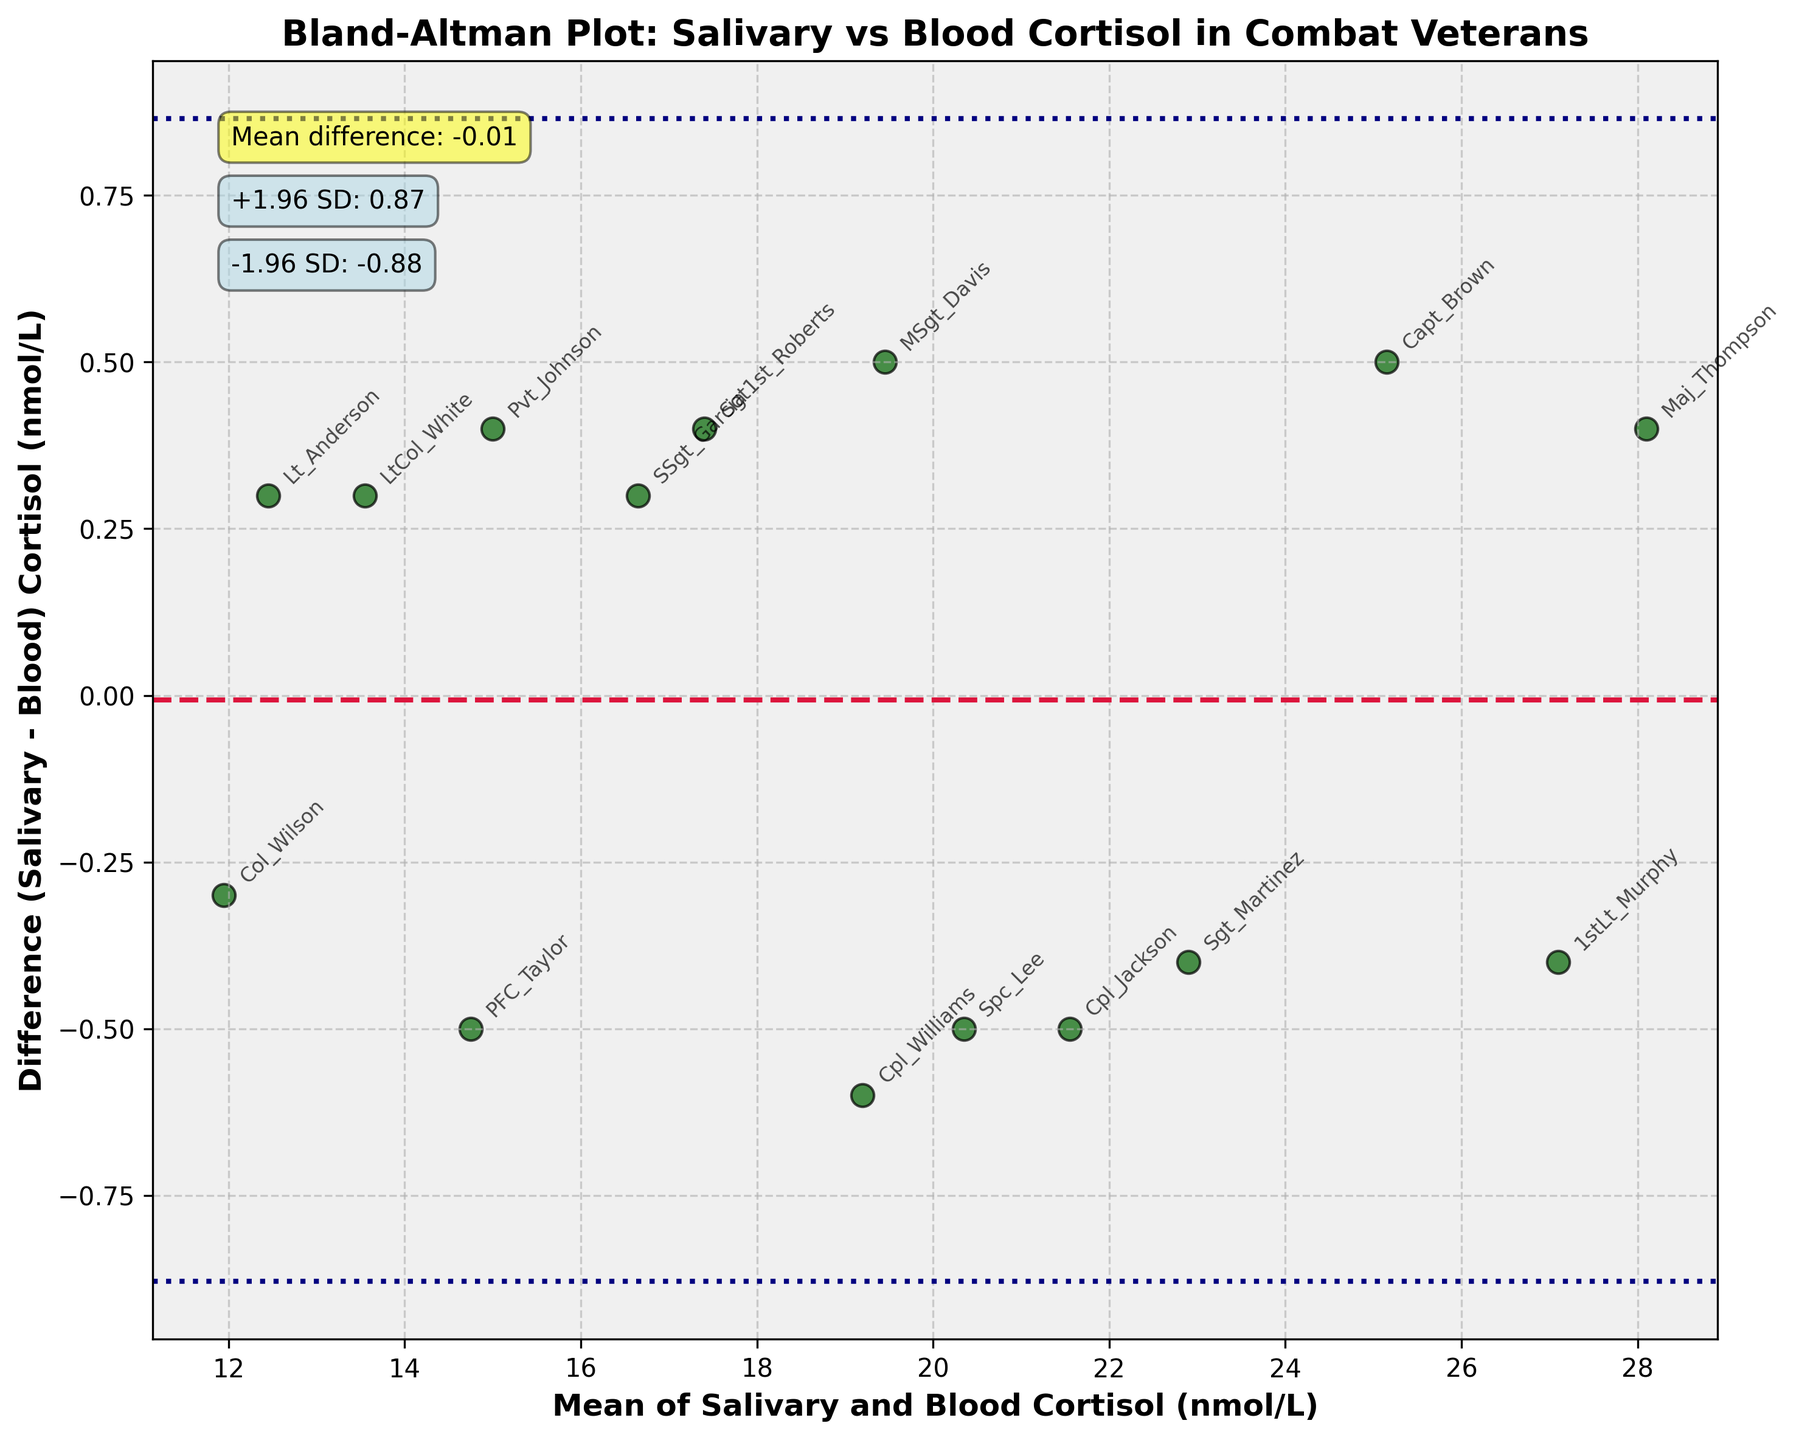What do the black dashed lines represent in the Bland-Altman plot? The black dashed lines represent the mean difference and the limits of agreement, which are calculated as the mean difference (+/-) 1.96 times the standard deviation. They help identify the range in which most of the differences between measurements fall.
Answer: Mean difference and limits of agreement Which subject has the maximum difference between salivary and blood cortisol levels? By observing the scatter plot, the point with the highest absolute value on the y-axis (difference) is checked. This corresponds to the subject "Maj_Thompson".
Answer: Maj_Thompson Which subject has a negative difference and what is its value? A negative difference would mean the salivary cortisol level is lower than the blood cortisol level. By looking at the points below the x-axis, the annotation shows "Capt_Brown" with a value around -0.5.
Answer: Capt_Brown, around -0.5 What is the mean difference between salivary and blood cortisol levels? The mean difference is indicated by the horizontal crimson dashed line and the annotation on the plot, which is approximately 0.02.
Answer: Approximately 0.02 What are the limits of agreement for the difference between the two cortisol measurements? The limits of agreement are read from the annotated text boxes. The top limit is around 1.60 and the bottom limit is around -1.56.
Answer: Around 1.60 and -1.56 Is the difference between salivary and blood cortisol levels generally within the limits of agreement? Most data points lie between the two horizontal dashed lines, which are the limits of agreement, indicating that the differences are generally within this range.
Answer: Yes Are there more data points with a positive or negative difference? By observing the plot, more points are found above the x-axis (positive difference) than below it (negative difference). Thus, there are more data points with a positive difference.
Answer: Positive Which subject has the smallest mean cortisol level and what is its value? This can be found by looking for the lowest x-coordinate among the points. "Col_Wilson" has the smallest mean cortisol level of around 12.
Answer: Col_Wilson, around 12 